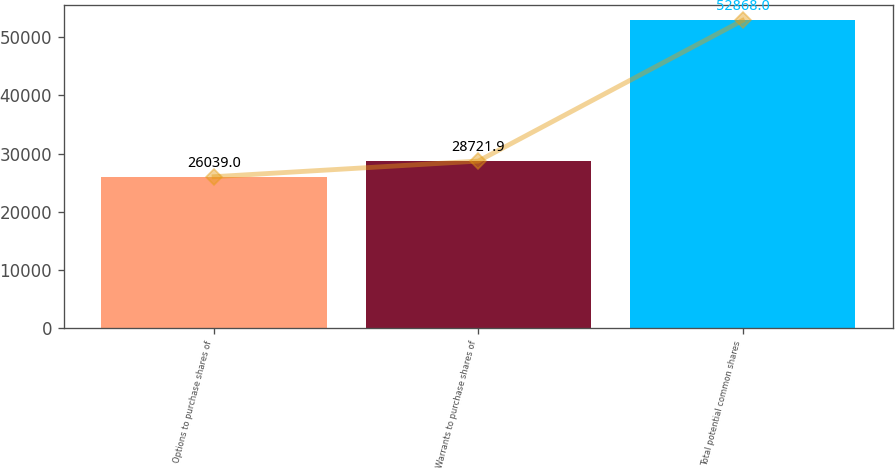Convert chart. <chart><loc_0><loc_0><loc_500><loc_500><bar_chart><fcel>Options to purchase shares of<fcel>Warrants to purchase shares of<fcel>Total potential common shares<nl><fcel>26039<fcel>28721.9<fcel>52868<nl></chart> 